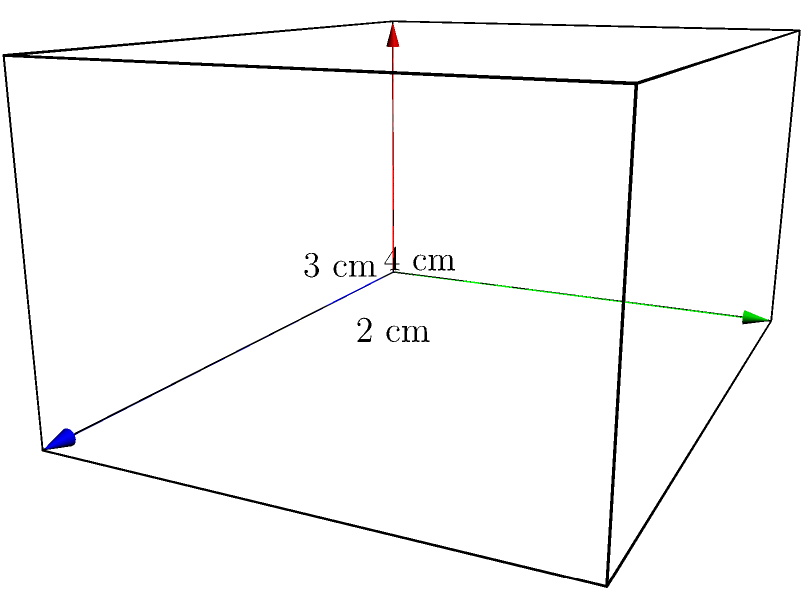A rectangular prism has dimensions as shown in the figure. Calculate the total surface area of the prism in square centimeters. To find the surface area of a rectangular prism, we need to calculate the area of all six faces and add them together. Let's break it down step by step:

1. Identify the dimensions:
   Length (l) = 4 cm
   Width (w) = 3 cm
   Height (h) = 2 cm

2. Calculate the areas of the faces:
   - Front and back faces (2 identical rectangles):
     Area = l × h = 4 cm × 2 cm = 8 cm²
     Total area = 2 × 8 cm² = 16 cm²

   - Top and bottom faces (2 identical rectangles):
     Area = l × w = 4 cm × 3 cm = 12 cm²
     Total area = 2 × 12 cm² = 24 cm²

   - Left and right faces (2 identical rectangles):
     Area = w × h = 3 cm × 2 cm = 6 cm²
     Total area = 2 × 6 cm² = 12 cm²

3. Sum up all the areas:
   Total surface area = 16 cm² + 24 cm² + 12 cm² = 52 cm²

Therefore, the total surface area of the rectangular prism is 52 square centimeters.
Answer: 52 cm² 